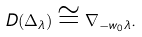Convert formula to latex. <formula><loc_0><loc_0><loc_500><loc_500>\ D ( \Delta _ { \lambda } ) \cong \nabla _ { - w _ { 0 } \lambda } .</formula> 